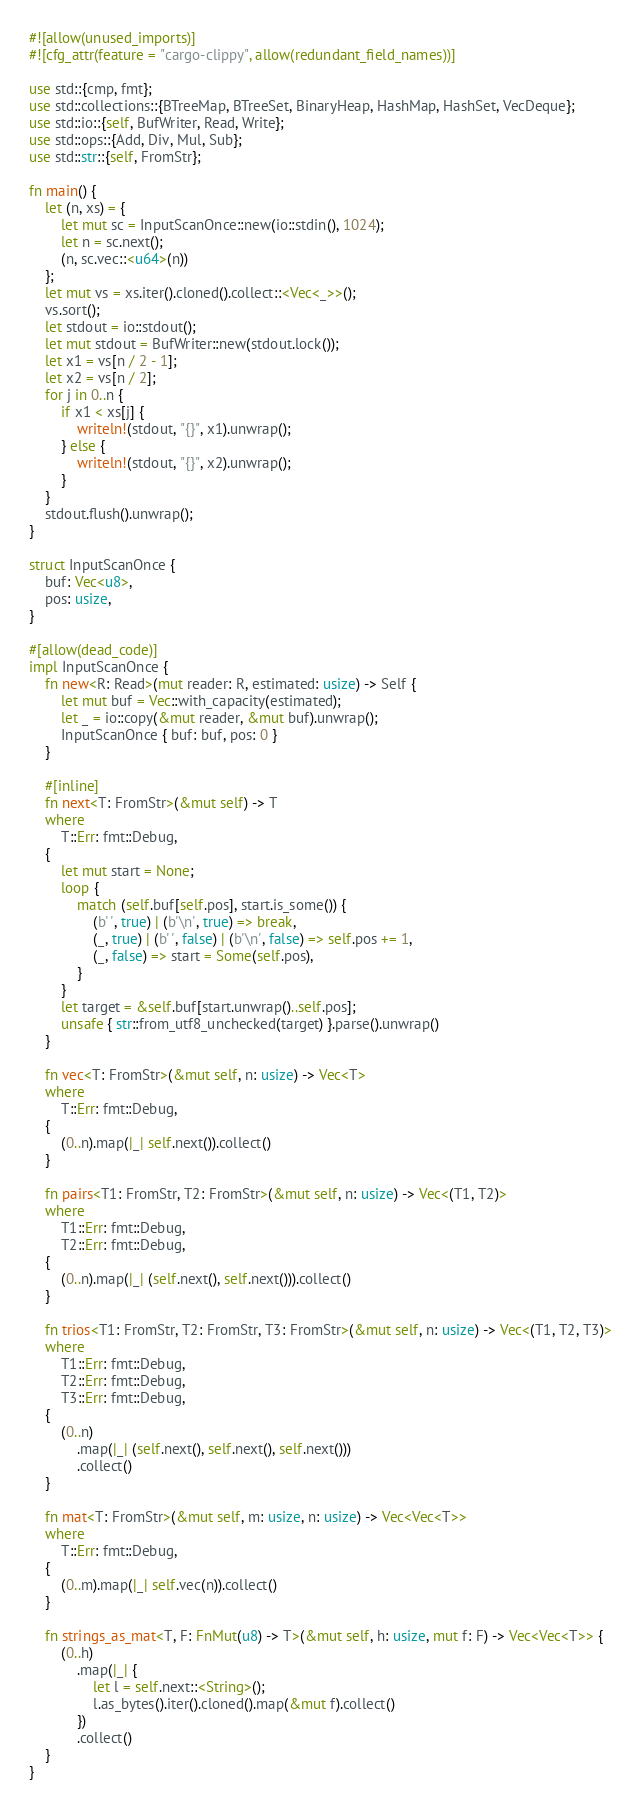Convert code to text. <code><loc_0><loc_0><loc_500><loc_500><_Rust_>#![allow(unused_imports)]
#![cfg_attr(feature = "cargo-clippy", allow(redundant_field_names))]

use std::{cmp, fmt};
use std::collections::{BTreeMap, BTreeSet, BinaryHeap, HashMap, HashSet, VecDeque};
use std::io::{self, BufWriter, Read, Write};
use std::ops::{Add, Div, Mul, Sub};
use std::str::{self, FromStr};

fn main() {
    let (n, xs) = {
        let mut sc = InputScanOnce::new(io::stdin(), 1024);
        let n = sc.next();
        (n, sc.vec::<u64>(n))
    };
    let mut vs = xs.iter().cloned().collect::<Vec<_>>();
    vs.sort();
    let stdout = io::stdout();
    let mut stdout = BufWriter::new(stdout.lock());
    let x1 = vs[n / 2 - 1];
    let x2 = vs[n / 2];
    for j in 0..n {
        if x1 < xs[j] {
            writeln!(stdout, "{}", x1).unwrap();
        } else {
            writeln!(stdout, "{}", x2).unwrap();
        }
    }
    stdout.flush().unwrap();
}

struct InputScanOnce {
    buf: Vec<u8>,
    pos: usize,
}

#[allow(dead_code)]
impl InputScanOnce {
    fn new<R: Read>(mut reader: R, estimated: usize) -> Self {
        let mut buf = Vec::with_capacity(estimated);
        let _ = io::copy(&mut reader, &mut buf).unwrap();
        InputScanOnce { buf: buf, pos: 0 }
    }

    #[inline]
    fn next<T: FromStr>(&mut self) -> T
    where
        T::Err: fmt::Debug,
    {
        let mut start = None;
        loop {
            match (self.buf[self.pos], start.is_some()) {
                (b' ', true) | (b'\n', true) => break,
                (_, true) | (b' ', false) | (b'\n', false) => self.pos += 1,
                (_, false) => start = Some(self.pos),
            }
        }
        let target = &self.buf[start.unwrap()..self.pos];
        unsafe { str::from_utf8_unchecked(target) }.parse().unwrap()
    }

    fn vec<T: FromStr>(&mut self, n: usize) -> Vec<T>
    where
        T::Err: fmt::Debug,
    {
        (0..n).map(|_| self.next()).collect()
    }

    fn pairs<T1: FromStr, T2: FromStr>(&mut self, n: usize) -> Vec<(T1, T2)>
    where
        T1::Err: fmt::Debug,
        T2::Err: fmt::Debug,
    {
        (0..n).map(|_| (self.next(), self.next())).collect()
    }

    fn trios<T1: FromStr, T2: FromStr, T3: FromStr>(&mut self, n: usize) -> Vec<(T1, T2, T3)>
    where
        T1::Err: fmt::Debug,
        T2::Err: fmt::Debug,
        T3::Err: fmt::Debug,
    {
        (0..n)
            .map(|_| (self.next(), self.next(), self.next()))
            .collect()
    }

    fn mat<T: FromStr>(&mut self, m: usize, n: usize) -> Vec<Vec<T>>
    where
        T::Err: fmt::Debug,
    {
        (0..m).map(|_| self.vec(n)).collect()
    }

    fn strings_as_mat<T, F: FnMut(u8) -> T>(&mut self, h: usize, mut f: F) -> Vec<Vec<T>> {
        (0..h)
            .map(|_| {
                let l = self.next::<String>();
                l.as_bytes().iter().cloned().map(&mut f).collect()
            })
            .collect()
    }
}
</code> 